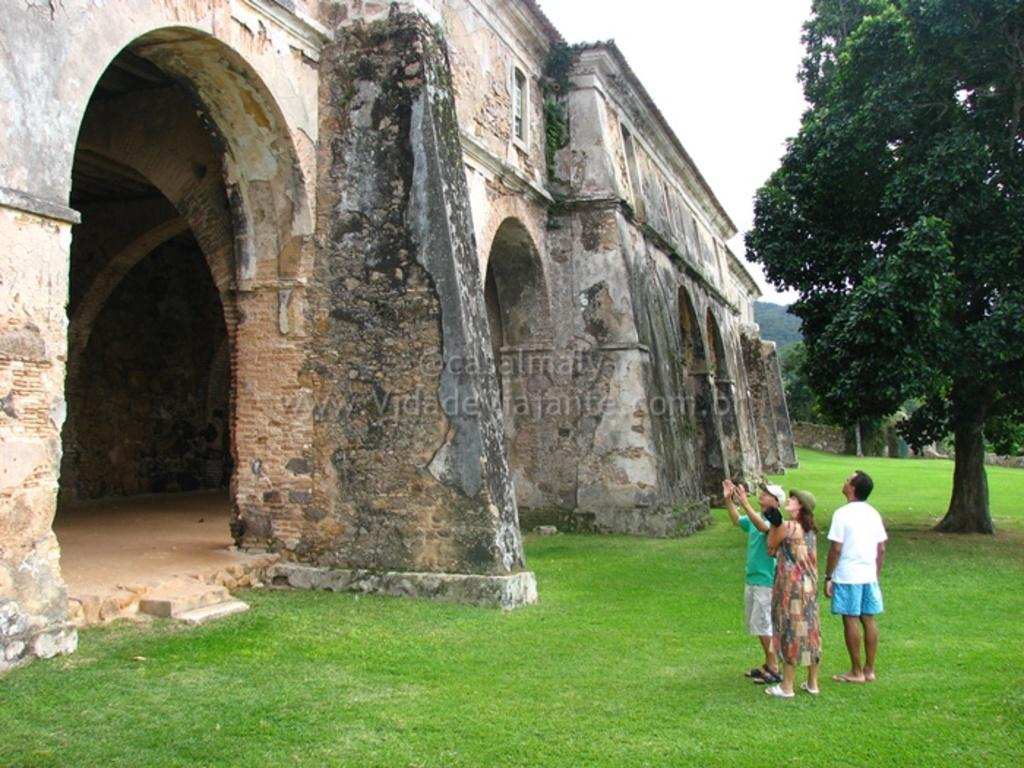What type of landscape is depicted in the image? There is a grassland in the image. How many people are present on the grassland? There are three persons on the grassland. What is located in front of the persons? There is a monument in front of the persons. What can be seen in the background of the image? There are trees in the background of the image. What type of flock is visible in the image? There is no flock visible in the image; it features a grassland, a monument, and trees. Can you tell me how many scissors are being used by the persons in the image? There is no indication that any scissors are being used by the persons in the image. 